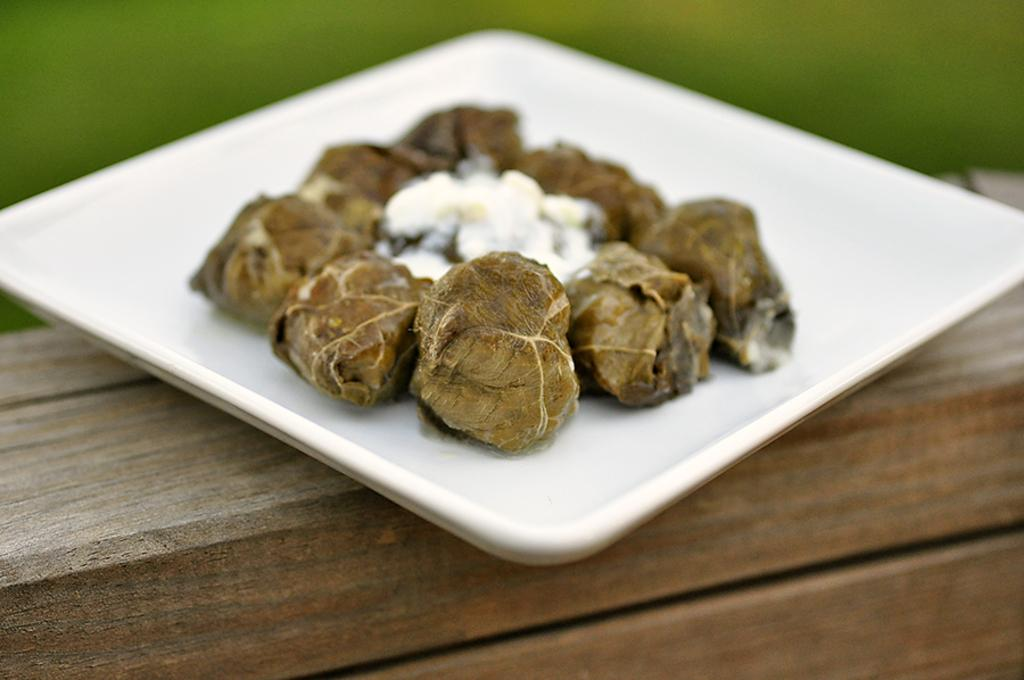What is on the plate that is visible in the image? There is a food item on a plate in the image. Where is the plate located? The plate is on a wooden board. Can you describe the background of the image? The background of the image is blurry. Can you tell me how many basketballs are visible in the image? There are no basketballs present in the image. What type of rub is being used to prepare the food item in the image? There is no rub or cooking process visible in the image; it only shows a food item on a plate. 